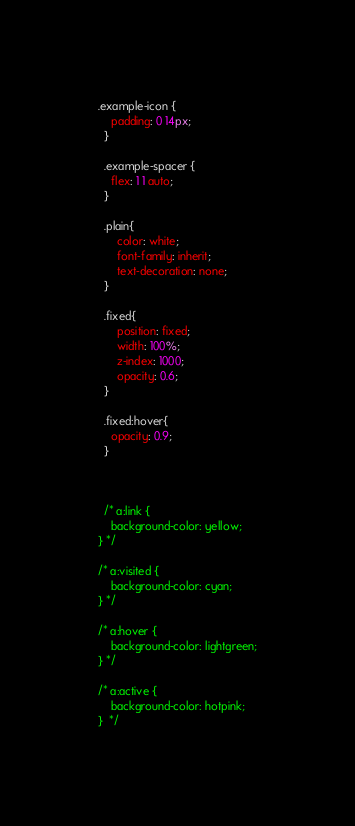Convert code to text. <code><loc_0><loc_0><loc_500><loc_500><_CSS_>.example-icon {
    padding: 0 14px;
  }
  
  .example-spacer {
    flex: 1 1 auto;
  }

  .plain{
      color: white;
      font-family: inherit;
      text-decoration: none;
  }

  .fixed{
      position: fixed;
      width: 100%;
      z-index: 1000;
      opacity: 0.6; 
  }

  .fixed:hover{
    opacity: 0.9; 
  }



  /* a:link {
    background-color: yellow;
} */

/* a:visited {
    background-color: cyan;
} */

/* a:hover {
    background-color: lightgreen;
} */

/* a:active {
    background-color: hotpink;
}  */</code> 